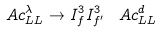Convert formula to latex. <formula><loc_0><loc_0><loc_500><loc_500>\ A c ^ { \lambda } _ { L L } \to I ^ { 3 } _ { f } I ^ { 3 } _ { f ^ { \prime } } \, \ A c ^ { d } _ { L L }</formula> 